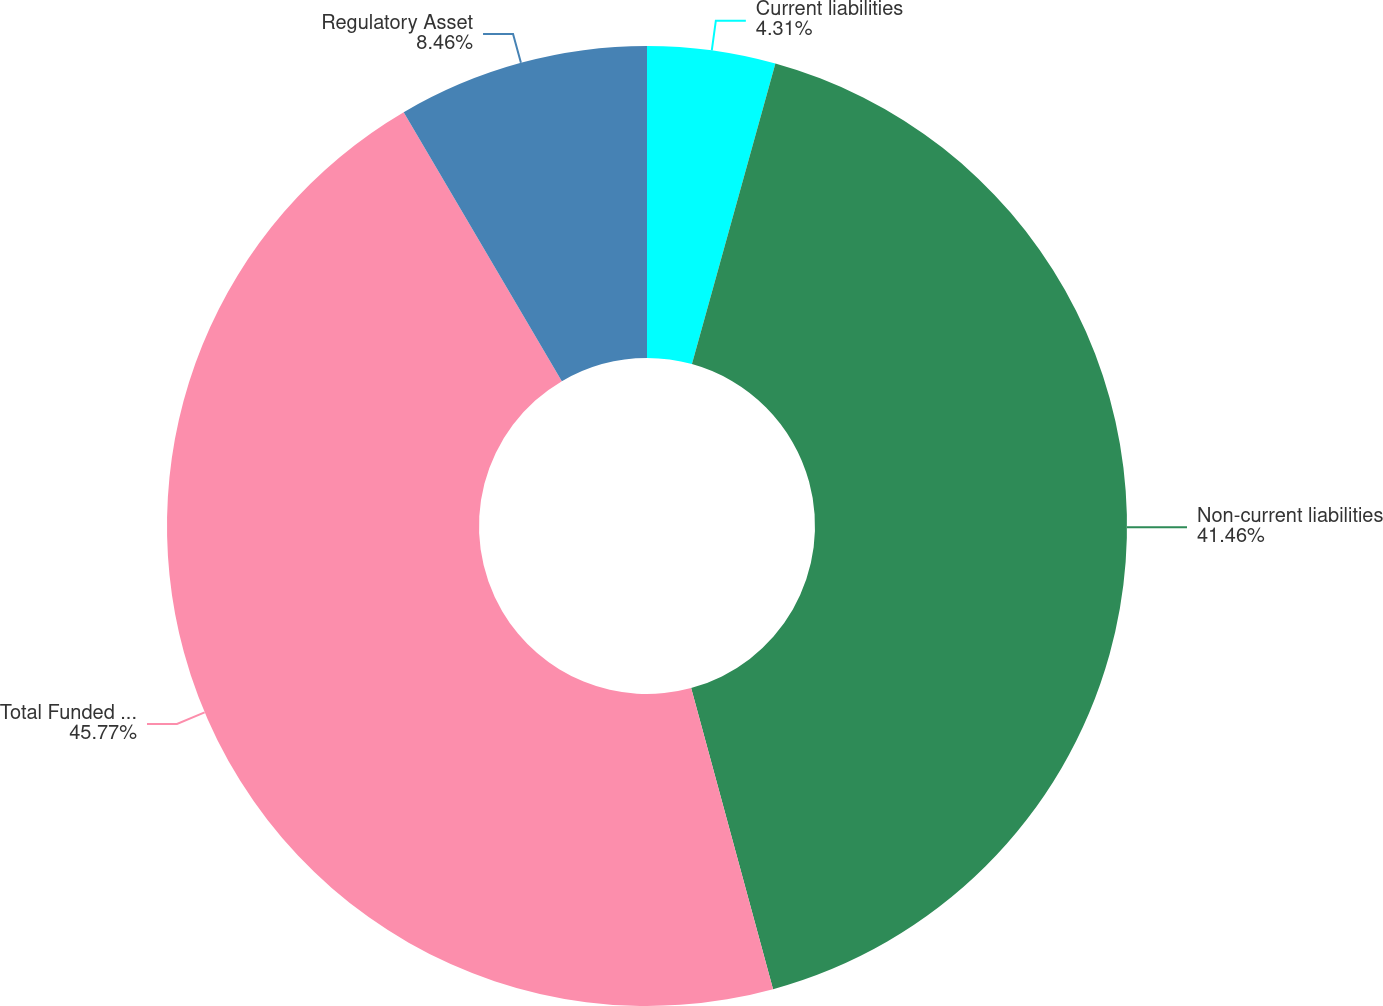Convert chart. <chart><loc_0><loc_0><loc_500><loc_500><pie_chart><fcel>Current liabilities<fcel>Non-current liabilities<fcel>Total Funded Status<fcel>Regulatory Asset<nl><fcel>4.31%<fcel>41.46%<fcel>45.77%<fcel>8.46%<nl></chart> 